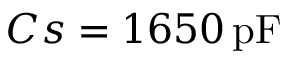<formula> <loc_0><loc_0><loc_500><loc_500>C s = 1 6 5 0 \, p F</formula> 